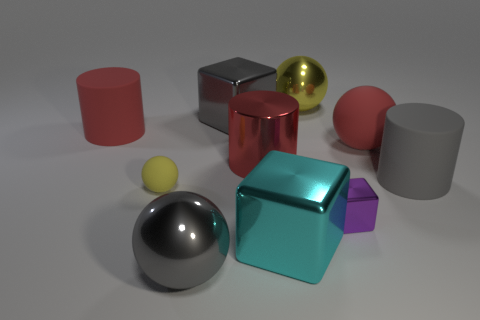There is a sphere that is both right of the small yellow rubber sphere and in front of the gray cylinder; what is it made of?
Your response must be concise. Metal. There is a yellow ball that is right of the big ball in front of the tiny ball; what size is it?
Provide a succinct answer. Large. Is there a large shiny object of the same color as the large matte ball?
Ensure brevity in your answer.  Yes. What number of tiny purple objects are the same material as the tiny yellow object?
Your response must be concise. 0. Do the gray thing that is in front of the tiny cube and the block that is in front of the small shiny cube have the same size?
Your answer should be compact. Yes. There is a tiny object on the right side of the big metal sphere in front of the tiny metallic thing; what is it made of?
Provide a succinct answer. Metal. Are there fewer small yellow spheres right of the large yellow metallic ball than gray things that are behind the small sphere?
Your answer should be very brief. Yes. What is the material of the big ball that is the same color as the small matte object?
Ensure brevity in your answer.  Metal. There is a small thing that is to the right of the gray sphere; what material is it?
Provide a short and direct response. Metal. There is a large yellow object; are there any big red shiny things right of it?
Give a very brief answer. No. 